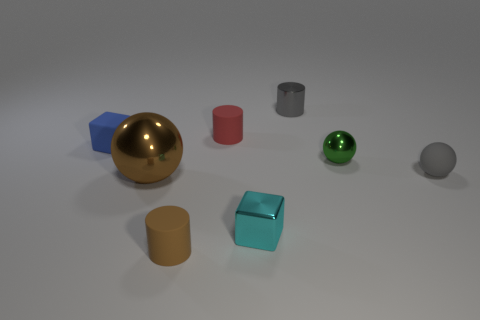There is a cylinder that is the same color as the large shiny thing; what is its material?
Provide a succinct answer. Rubber. Are there an equal number of tiny green objects that are to the left of the blue object and big purple rubber things?
Provide a short and direct response. Yes. Is the big brown ball made of the same material as the small red object?
Offer a very short reply. No. There is a thing that is both behind the shiny block and in front of the tiny gray ball; what size is it?
Make the answer very short. Large. How many blue blocks are the same size as the blue thing?
Provide a succinct answer. 0. What size is the shiny object to the left of the tiny matte cylinder to the left of the small red matte cylinder?
Your answer should be very brief. Large. There is a small metallic thing behind the small blue matte block; is it the same shape as the tiny brown object that is in front of the green object?
Make the answer very short. Yes. There is a matte object that is right of the tiny blue block and behind the tiny gray rubber sphere; what is its color?
Your answer should be compact. Red. Is there a small metal cylinder that has the same color as the big sphere?
Provide a succinct answer. No. There is a rubber object that is in front of the small gray sphere; what is its color?
Give a very brief answer. Brown. 